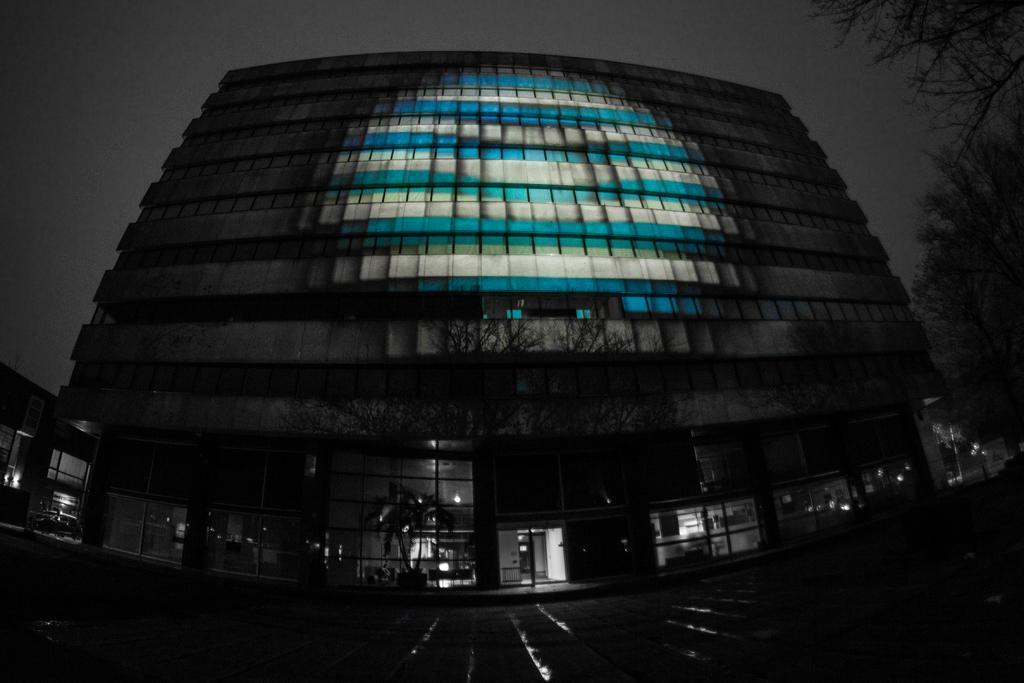Describe this image in one or two sentences. In this image, we can see a building and we can see trees on the right side. At the top we can see the sky. 